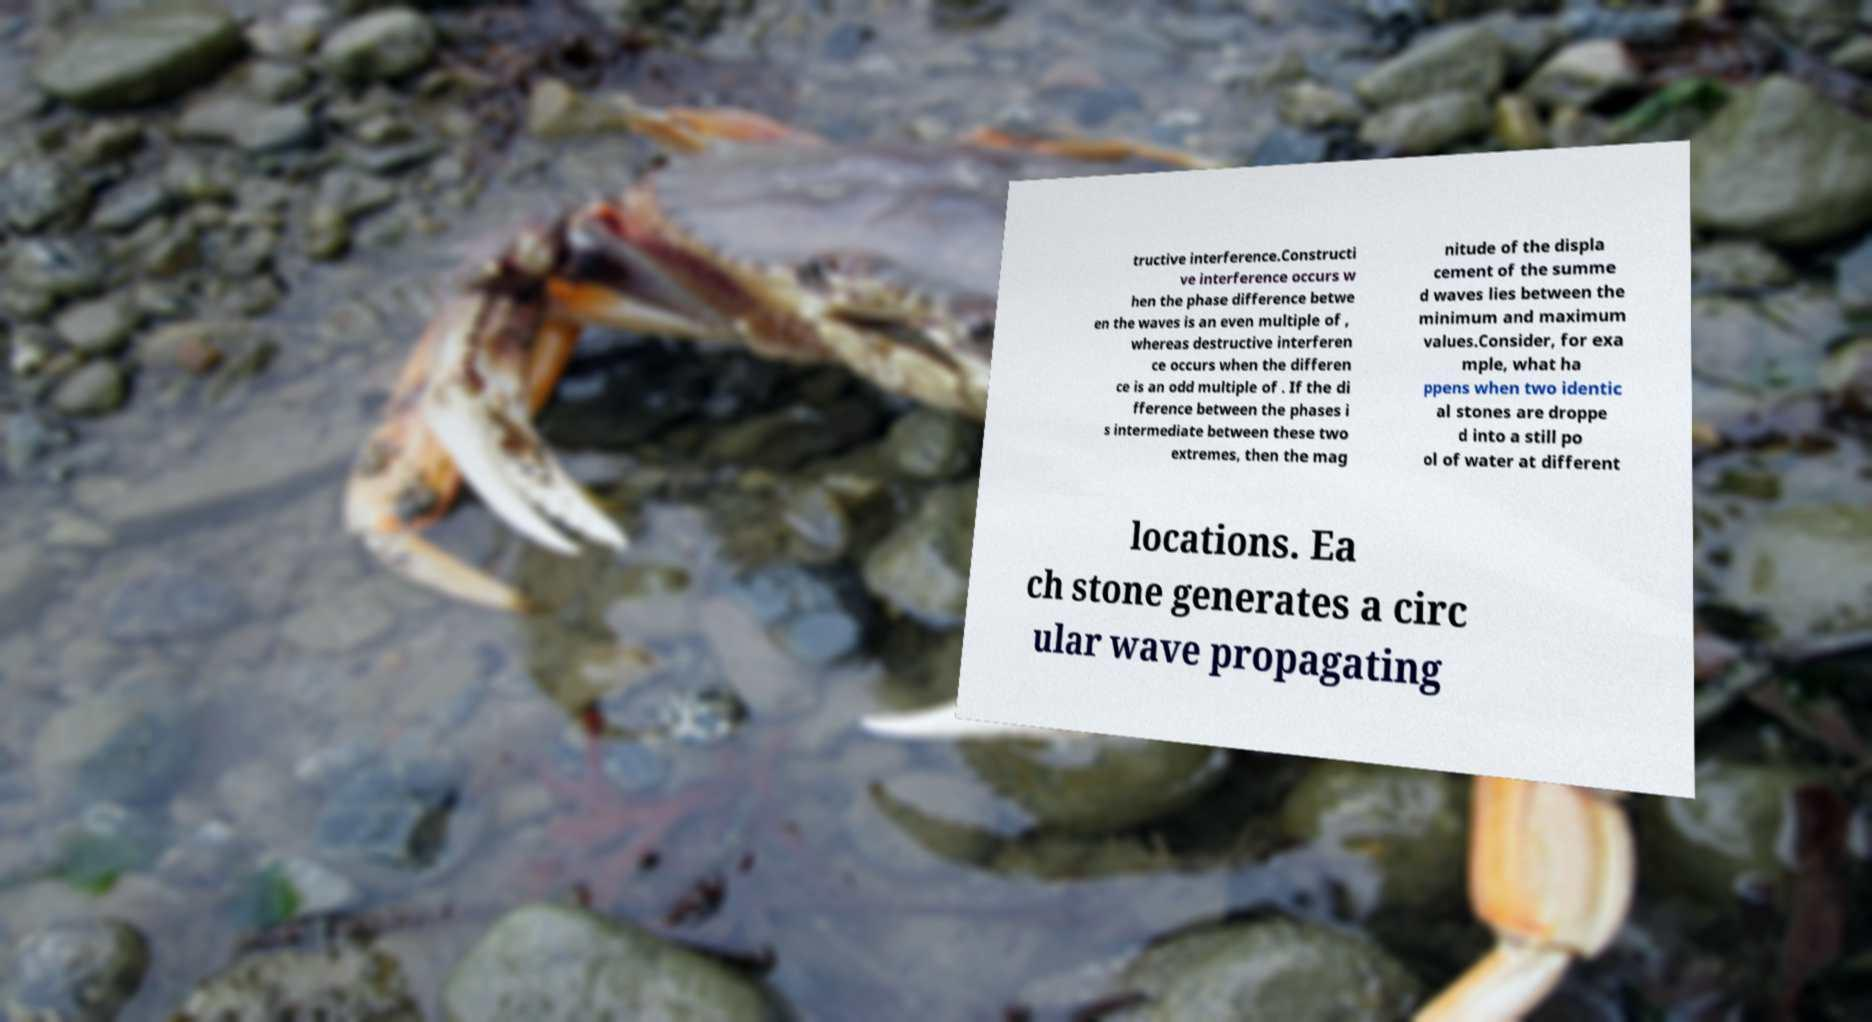Can you read and provide the text displayed in the image?This photo seems to have some interesting text. Can you extract and type it out for me? tructive interference.Constructi ve interference occurs w hen the phase difference betwe en the waves is an even multiple of , whereas destructive interferen ce occurs when the differen ce is an odd multiple of . If the di fference between the phases i s intermediate between these two extremes, then the mag nitude of the displa cement of the summe d waves lies between the minimum and maximum values.Consider, for exa mple, what ha ppens when two identic al stones are droppe d into a still po ol of water at different locations. Ea ch stone generates a circ ular wave propagating 